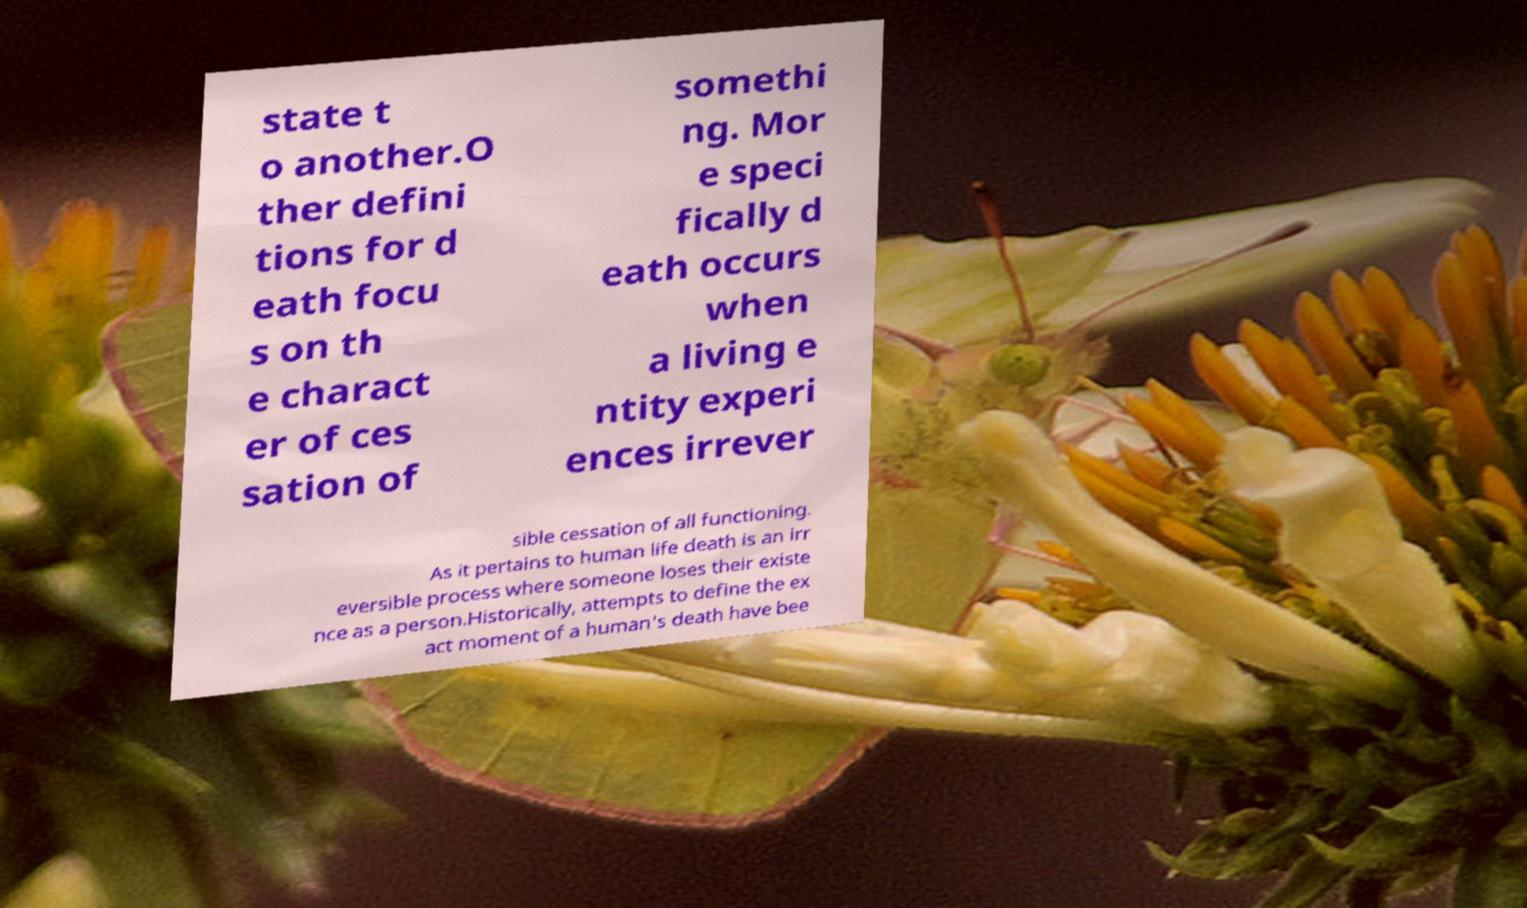Please identify and transcribe the text found in this image. state t o another.O ther defini tions for d eath focu s on th e charact er of ces sation of somethi ng. Mor e speci fically d eath occurs when a living e ntity experi ences irrever sible cessation of all functioning. As it pertains to human life death is an irr eversible process where someone loses their existe nce as a person.Historically, attempts to define the ex act moment of a human's death have bee 